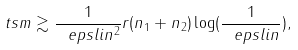Convert formula to latex. <formula><loc_0><loc_0><loc_500><loc_500>\ t s m \gtrsim \frac { 1 } { \ e p s l i n ^ { 2 } } r ( n _ { 1 } + n _ { 2 } ) \log ( \frac { 1 } { \ e p s l i n } ) ,</formula> 